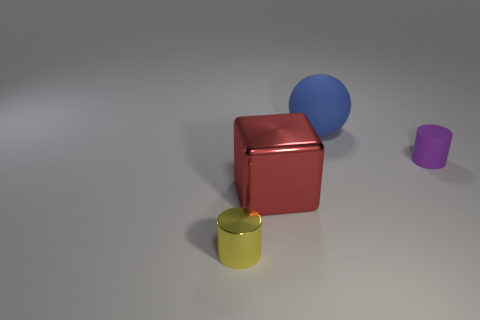Add 3 large gray metal blocks. How many objects exist? 7 Subtract all cubes. How many objects are left? 3 Subtract 0 gray spheres. How many objects are left? 4 Subtract all big cyan matte cylinders. Subtract all large red metal cubes. How many objects are left? 3 Add 3 big red shiny objects. How many big red shiny objects are left? 4 Add 2 red matte cylinders. How many red matte cylinders exist? 2 